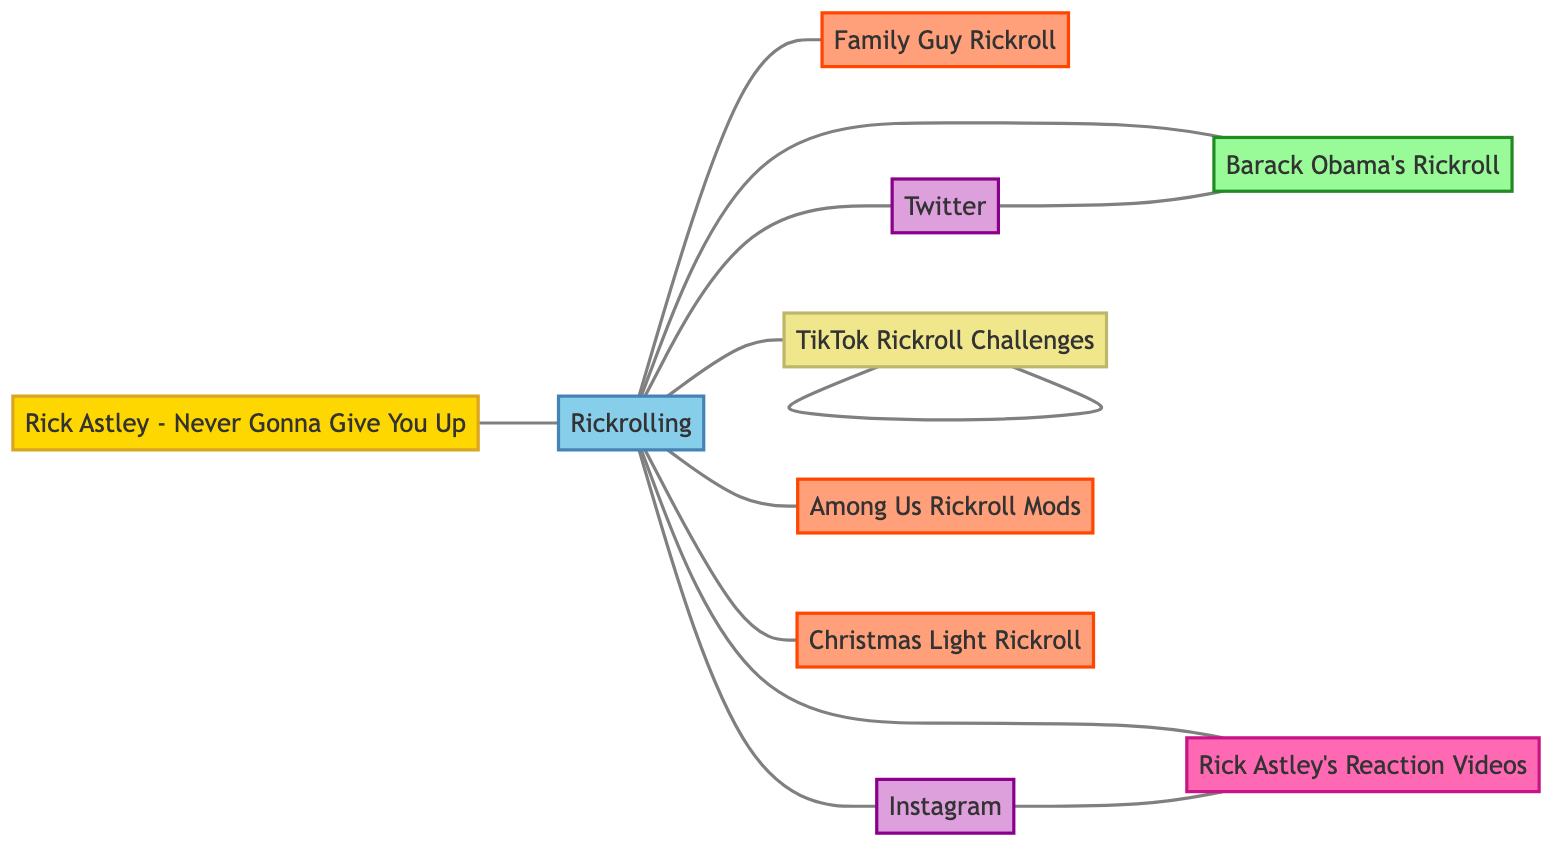What is the total number of nodes in the diagram? The diagram lists the following nodes: "Rick Astley - Never Gonna Give You Up", "Rickrolling", "Barack Obama's Rickroll", "Family Guy Rickroll", "Instagram", "Twitter", "TikTok Rickroll Challenges", "Rick Astley's Reaction Videos", "Among Us Rickroll Mods", and "Christmas Light Rickroll", which totals to ten.
Answer: 10 Which node represents the original meme? In the diagram, the node labeled "Rick Astley - Never Gonna Give You Up" specifically serves as the original meme, making it easily identifiable as such.
Answer: Rick Astley - Never Gonna Give You Up How many edges are connected to the "Rickrolling" node? By examining the connections, the "Rickrolling" node is connected to eleven edges, linking it to various other nodes including remixes and adaptations of the original meme.
Answer: 11 What category does "TikTok Rickroll Challenges" fall under? The node "TikTok Rickroll Challenges" is categorized under "Social Media Trend", which is indicated by its label and coloring in the diagram.
Answer: Social Media Trend Which notable remix is connected to both "Rickrolling" and "Twitter"? By following the connections, "Barack Obama's Rickroll" is the notable remix that has edges both leading to and from ["Rickrolling"] and ["Twitter"].
Answer: Barack Obama's Rickroll Which node has a direct connection to both "Instagram" and the "Rick Astley's Reaction Videos"? The "Rickrolling" node serves as a central hub, having direct connections to both "Instagram" and "Rick Astley's Reaction Videos," showcasing its importance in the meme narrative.
Answer: Rickrolling How many social media platforms are represented in the diagram? The diagram identifies two distinct nodes labeled as social media platforms: "Instagram" and "Twitter". Thus, the total count of social media platforms represented is two.
Answer: 2 What is the relationship between "Rick Astley's Reaction Videos" and "Rickrolling"? The relationship between these two nodes is that “Rick Astley’s Reaction Videos” is directly connected to “Rickrolling,” indicating an interaction stemming from the original meme.
Answer: They are directly connected Which adaptation is specifically mentioned as seasonal? The node labeled “Christmas Light Rickroll” is explicitly categorized as a seasonal variant, indicating its specific adaptation based on a holiday theme.
Answer: Christmas Light Rickroll 